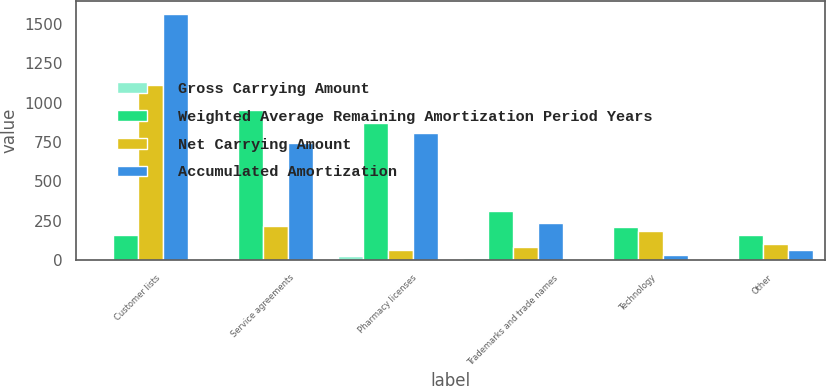Convert chart to OTSL. <chart><loc_0><loc_0><loc_500><loc_500><stacked_bar_chart><ecel><fcel>Customer lists<fcel>Service agreements<fcel>Pharmacy licenses<fcel>Trademarks and trade names<fcel>Technology<fcel>Other<nl><fcel>Gross Carrying Amount<fcel>8<fcel>15<fcel>26<fcel>15<fcel>3<fcel>4<nl><fcel>Weighted Average Remaining Amortization Period Years<fcel>162<fcel>957<fcel>874<fcel>315<fcel>213<fcel>162<nl><fcel>Net Carrying Amount<fcel>1116<fcel>215<fcel>65<fcel>82<fcel>184<fcel>101<nl><fcel>Accumulated Amortization<fcel>1567<fcel>742<fcel>809<fcel>233<fcel>29<fcel>61<nl></chart> 